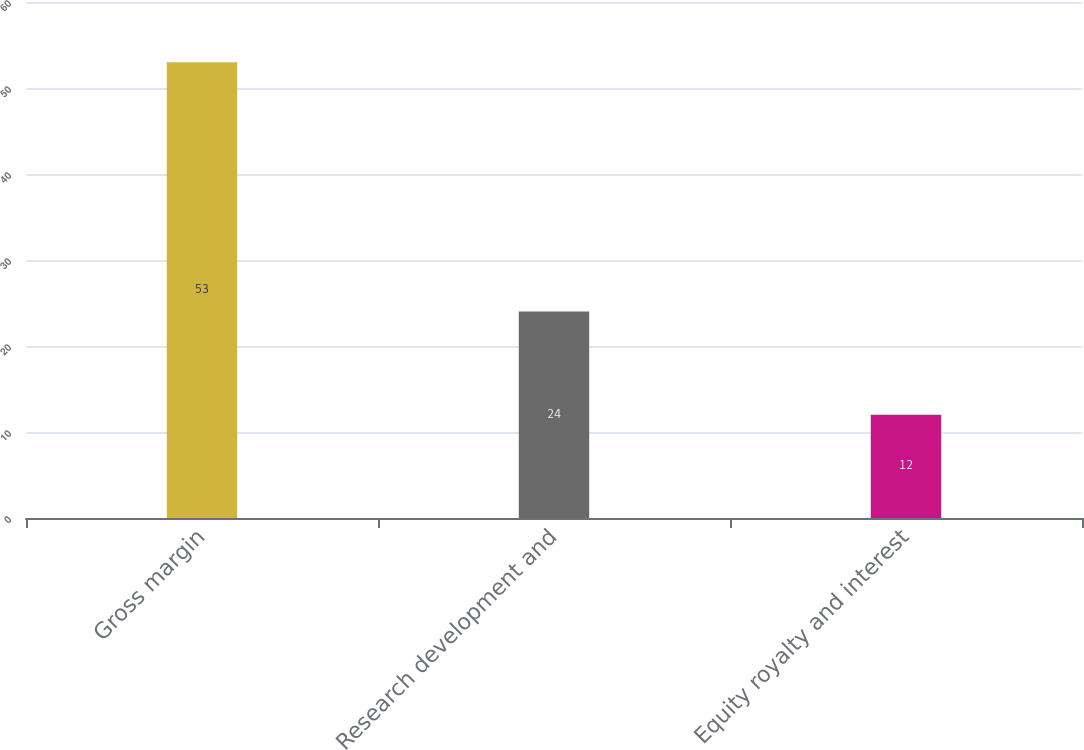Convert chart. <chart><loc_0><loc_0><loc_500><loc_500><bar_chart><fcel>Gross margin<fcel>Research development and<fcel>Equity royalty and interest<nl><fcel>53<fcel>24<fcel>12<nl></chart> 